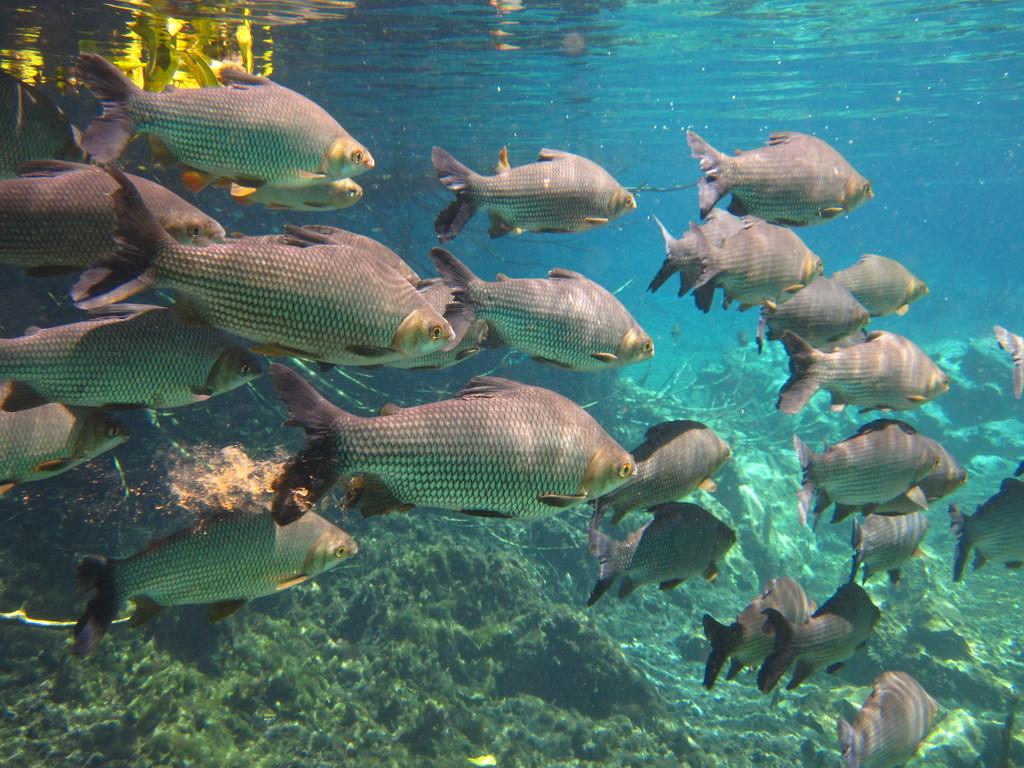What type of animals can be seen in the image? There are fishes visible in the image. Where are the fishes located in relation to the water? The fishes are below the surface of the water. What type of jeans is the fish wearing in the image? There are no jeans present in the image, as fishes do not wear clothing. 